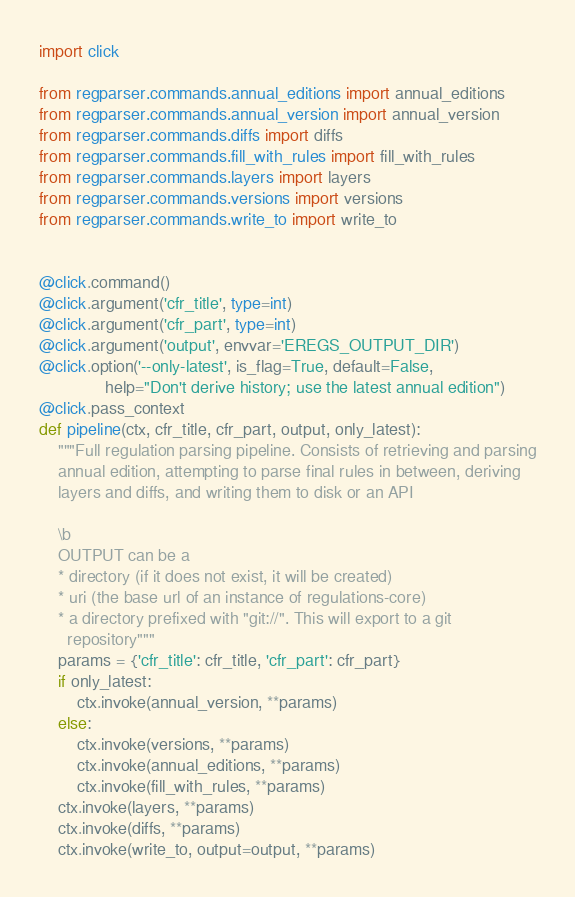<code> <loc_0><loc_0><loc_500><loc_500><_Python_>import click

from regparser.commands.annual_editions import annual_editions
from regparser.commands.annual_version import annual_version
from regparser.commands.diffs import diffs
from regparser.commands.fill_with_rules import fill_with_rules
from regparser.commands.layers import layers
from regparser.commands.versions import versions
from regparser.commands.write_to import write_to


@click.command()
@click.argument('cfr_title', type=int)
@click.argument('cfr_part', type=int)
@click.argument('output', envvar='EREGS_OUTPUT_DIR')
@click.option('--only-latest', is_flag=True, default=False,
              help="Don't derive history; use the latest annual edition")
@click.pass_context
def pipeline(ctx, cfr_title, cfr_part, output, only_latest):
    """Full regulation parsing pipeline. Consists of retrieving and parsing
    annual edition, attempting to parse final rules in between, deriving
    layers and diffs, and writing them to disk or an API

    \b
    OUTPUT can be a
    * directory (if it does not exist, it will be created)
    * uri (the base url of an instance of regulations-core)
    * a directory prefixed with "git://". This will export to a git
      repository"""
    params = {'cfr_title': cfr_title, 'cfr_part': cfr_part}
    if only_latest:
        ctx.invoke(annual_version, **params)
    else:
        ctx.invoke(versions, **params)
        ctx.invoke(annual_editions, **params)
        ctx.invoke(fill_with_rules, **params)
    ctx.invoke(layers, **params)
    ctx.invoke(diffs, **params)
    ctx.invoke(write_to, output=output, **params)
</code> 